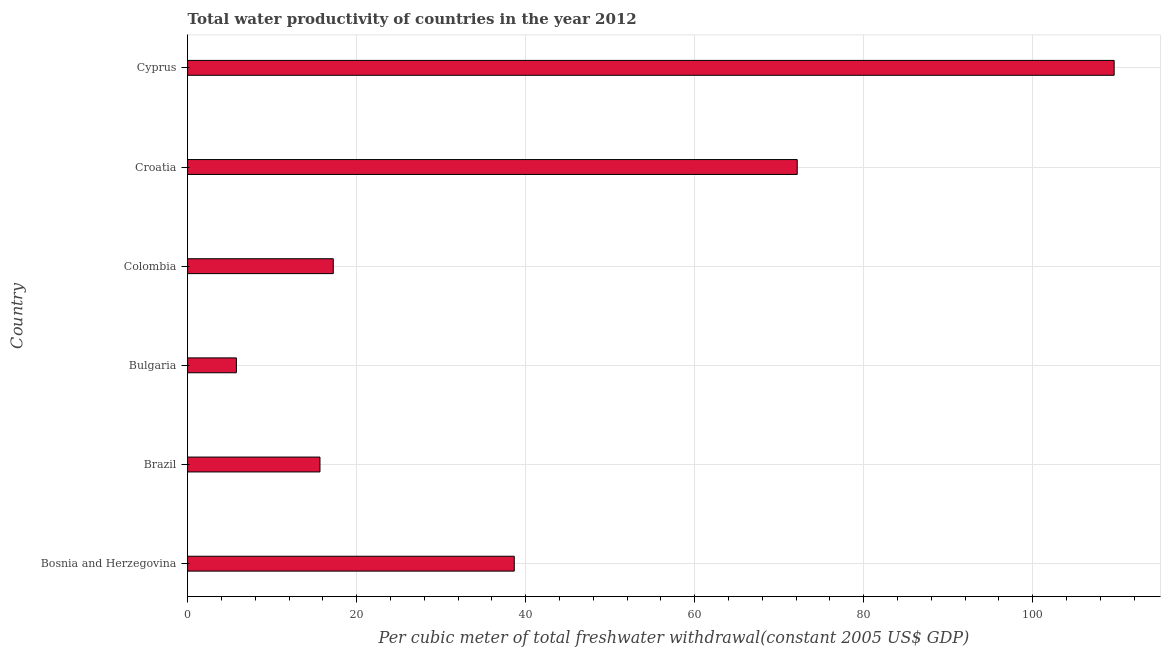Does the graph contain any zero values?
Provide a short and direct response. No. Does the graph contain grids?
Keep it short and to the point. Yes. What is the title of the graph?
Provide a succinct answer. Total water productivity of countries in the year 2012. What is the label or title of the X-axis?
Your answer should be very brief. Per cubic meter of total freshwater withdrawal(constant 2005 US$ GDP). What is the label or title of the Y-axis?
Make the answer very short. Country. What is the total water productivity in Bulgaria?
Ensure brevity in your answer.  5.78. Across all countries, what is the maximum total water productivity?
Your response must be concise. 109.65. Across all countries, what is the minimum total water productivity?
Offer a very short reply. 5.78. In which country was the total water productivity maximum?
Your answer should be very brief. Cyprus. What is the sum of the total water productivity?
Make the answer very short. 259.12. What is the difference between the total water productivity in Brazil and Bulgaria?
Your response must be concise. 9.89. What is the average total water productivity per country?
Ensure brevity in your answer.  43.19. What is the median total water productivity?
Offer a very short reply. 27.95. What is the ratio of the total water productivity in Croatia to that in Cyprus?
Provide a short and direct response. 0.66. What is the difference between the highest and the second highest total water productivity?
Offer a very short reply. 37.51. What is the difference between the highest and the lowest total water productivity?
Provide a short and direct response. 103.87. In how many countries, is the total water productivity greater than the average total water productivity taken over all countries?
Make the answer very short. 2. How many bars are there?
Make the answer very short. 6. Are all the bars in the graph horizontal?
Provide a short and direct response. Yes. Are the values on the major ticks of X-axis written in scientific E-notation?
Provide a succinct answer. No. What is the Per cubic meter of total freshwater withdrawal(constant 2005 US$ GDP) of Bosnia and Herzegovina?
Give a very brief answer. 38.66. What is the Per cubic meter of total freshwater withdrawal(constant 2005 US$ GDP) in Brazil?
Your answer should be compact. 15.66. What is the Per cubic meter of total freshwater withdrawal(constant 2005 US$ GDP) of Bulgaria?
Give a very brief answer. 5.78. What is the Per cubic meter of total freshwater withdrawal(constant 2005 US$ GDP) in Colombia?
Offer a terse response. 17.24. What is the Per cubic meter of total freshwater withdrawal(constant 2005 US$ GDP) of Croatia?
Offer a very short reply. 72.14. What is the Per cubic meter of total freshwater withdrawal(constant 2005 US$ GDP) of Cyprus?
Keep it short and to the point. 109.65. What is the difference between the Per cubic meter of total freshwater withdrawal(constant 2005 US$ GDP) in Bosnia and Herzegovina and Brazil?
Ensure brevity in your answer.  22.99. What is the difference between the Per cubic meter of total freshwater withdrawal(constant 2005 US$ GDP) in Bosnia and Herzegovina and Bulgaria?
Make the answer very short. 32.88. What is the difference between the Per cubic meter of total freshwater withdrawal(constant 2005 US$ GDP) in Bosnia and Herzegovina and Colombia?
Provide a succinct answer. 21.42. What is the difference between the Per cubic meter of total freshwater withdrawal(constant 2005 US$ GDP) in Bosnia and Herzegovina and Croatia?
Offer a very short reply. -33.48. What is the difference between the Per cubic meter of total freshwater withdrawal(constant 2005 US$ GDP) in Bosnia and Herzegovina and Cyprus?
Make the answer very short. -70.99. What is the difference between the Per cubic meter of total freshwater withdrawal(constant 2005 US$ GDP) in Brazil and Bulgaria?
Provide a short and direct response. 9.89. What is the difference between the Per cubic meter of total freshwater withdrawal(constant 2005 US$ GDP) in Brazil and Colombia?
Your response must be concise. -1.57. What is the difference between the Per cubic meter of total freshwater withdrawal(constant 2005 US$ GDP) in Brazil and Croatia?
Offer a terse response. -56.48. What is the difference between the Per cubic meter of total freshwater withdrawal(constant 2005 US$ GDP) in Brazil and Cyprus?
Provide a succinct answer. -93.98. What is the difference between the Per cubic meter of total freshwater withdrawal(constant 2005 US$ GDP) in Bulgaria and Colombia?
Keep it short and to the point. -11.46. What is the difference between the Per cubic meter of total freshwater withdrawal(constant 2005 US$ GDP) in Bulgaria and Croatia?
Keep it short and to the point. -66.37. What is the difference between the Per cubic meter of total freshwater withdrawal(constant 2005 US$ GDP) in Bulgaria and Cyprus?
Your response must be concise. -103.87. What is the difference between the Per cubic meter of total freshwater withdrawal(constant 2005 US$ GDP) in Colombia and Croatia?
Offer a terse response. -54.9. What is the difference between the Per cubic meter of total freshwater withdrawal(constant 2005 US$ GDP) in Colombia and Cyprus?
Offer a very short reply. -92.41. What is the difference between the Per cubic meter of total freshwater withdrawal(constant 2005 US$ GDP) in Croatia and Cyprus?
Ensure brevity in your answer.  -37.51. What is the ratio of the Per cubic meter of total freshwater withdrawal(constant 2005 US$ GDP) in Bosnia and Herzegovina to that in Brazil?
Your answer should be compact. 2.47. What is the ratio of the Per cubic meter of total freshwater withdrawal(constant 2005 US$ GDP) in Bosnia and Herzegovina to that in Bulgaria?
Your answer should be compact. 6.69. What is the ratio of the Per cubic meter of total freshwater withdrawal(constant 2005 US$ GDP) in Bosnia and Herzegovina to that in Colombia?
Provide a short and direct response. 2.24. What is the ratio of the Per cubic meter of total freshwater withdrawal(constant 2005 US$ GDP) in Bosnia and Herzegovina to that in Croatia?
Give a very brief answer. 0.54. What is the ratio of the Per cubic meter of total freshwater withdrawal(constant 2005 US$ GDP) in Bosnia and Herzegovina to that in Cyprus?
Offer a terse response. 0.35. What is the ratio of the Per cubic meter of total freshwater withdrawal(constant 2005 US$ GDP) in Brazil to that in Bulgaria?
Make the answer very short. 2.71. What is the ratio of the Per cubic meter of total freshwater withdrawal(constant 2005 US$ GDP) in Brazil to that in Colombia?
Give a very brief answer. 0.91. What is the ratio of the Per cubic meter of total freshwater withdrawal(constant 2005 US$ GDP) in Brazil to that in Croatia?
Provide a short and direct response. 0.22. What is the ratio of the Per cubic meter of total freshwater withdrawal(constant 2005 US$ GDP) in Brazil to that in Cyprus?
Provide a short and direct response. 0.14. What is the ratio of the Per cubic meter of total freshwater withdrawal(constant 2005 US$ GDP) in Bulgaria to that in Colombia?
Your answer should be very brief. 0.34. What is the ratio of the Per cubic meter of total freshwater withdrawal(constant 2005 US$ GDP) in Bulgaria to that in Croatia?
Your answer should be very brief. 0.08. What is the ratio of the Per cubic meter of total freshwater withdrawal(constant 2005 US$ GDP) in Bulgaria to that in Cyprus?
Keep it short and to the point. 0.05. What is the ratio of the Per cubic meter of total freshwater withdrawal(constant 2005 US$ GDP) in Colombia to that in Croatia?
Your answer should be very brief. 0.24. What is the ratio of the Per cubic meter of total freshwater withdrawal(constant 2005 US$ GDP) in Colombia to that in Cyprus?
Your answer should be very brief. 0.16. What is the ratio of the Per cubic meter of total freshwater withdrawal(constant 2005 US$ GDP) in Croatia to that in Cyprus?
Your answer should be compact. 0.66. 